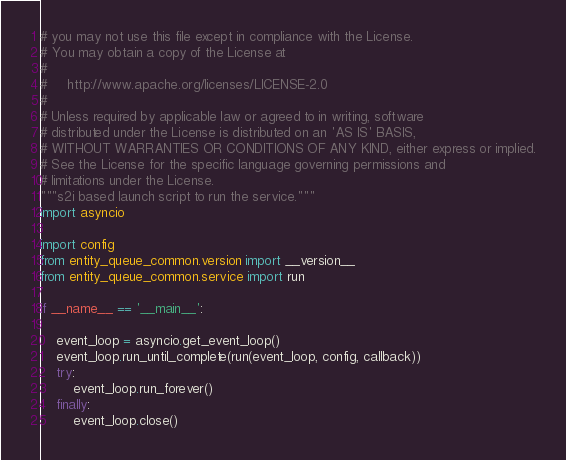<code> <loc_0><loc_0><loc_500><loc_500><_Python_># you may not use this file except in compliance with the License.
# You may obtain a copy of the License at
#
#     http://www.apache.org/licenses/LICENSE-2.0
#
# Unless required by applicable law or agreed to in writing, software
# distributed under the License is distributed on an 'AS IS' BASIS,
# WITHOUT WARRANTIES OR CONDITIONS OF ANY KIND, either express or implied.
# See the License for the specific language governing permissions and
# limitations under the License.
"""s2i based launch script to run the service."""
import asyncio

import config
from entity_queue_common.version import __version__
from entity_queue_common.service import run

if __name__ == '__main__':

    event_loop = asyncio.get_event_loop()
    event_loop.run_until_complete(run(event_loop, config, callback))
    try:
        event_loop.run_forever()
    finally:
        event_loop.close()
</code> 